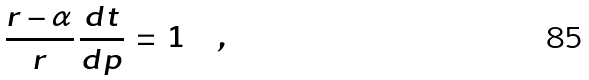<formula> <loc_0><loc_0><loc_500><loc_500>\frac { r - \alpha } { r } \, \frac { d t } { d p } \, = \, 1 \quad ,</formula> 